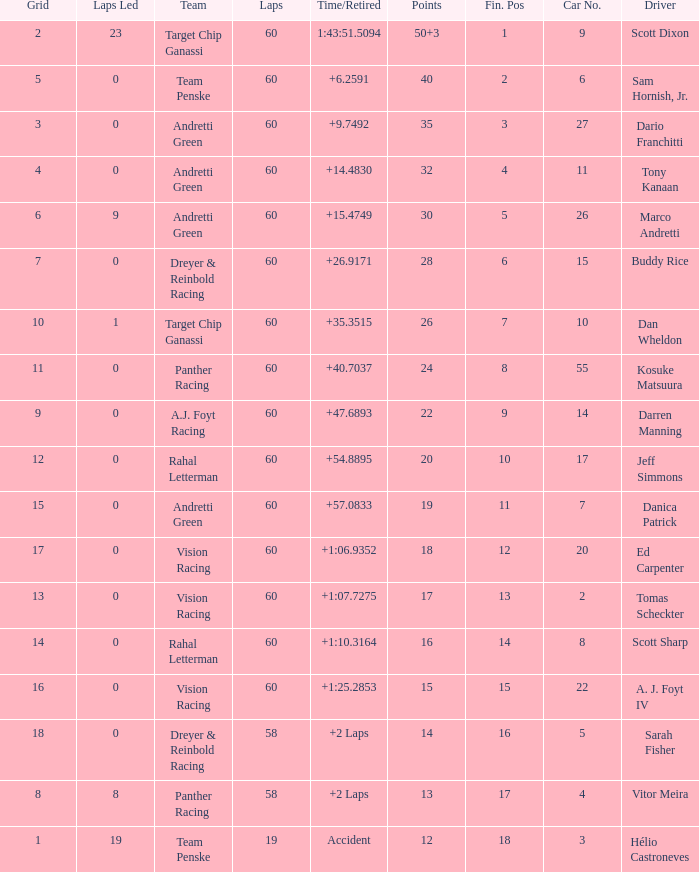List the laps that are equivalent to 18 points. 60.0. 